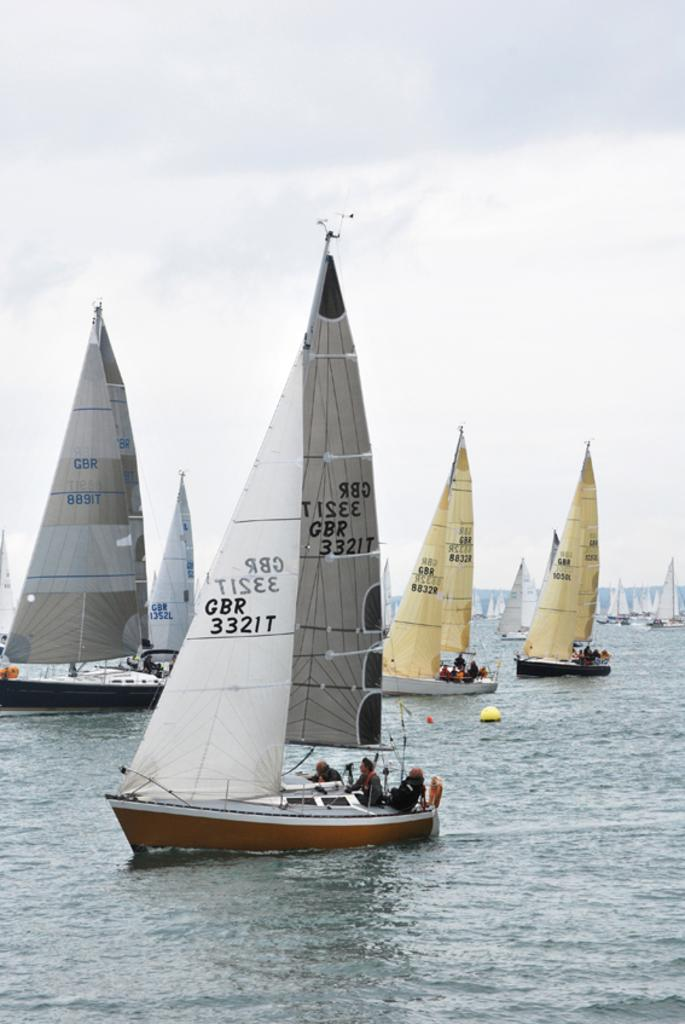<image>
Create a compact narrative representing the image presented. A group of sailboats with the one in the foreground having GBR332IT on the sail. 